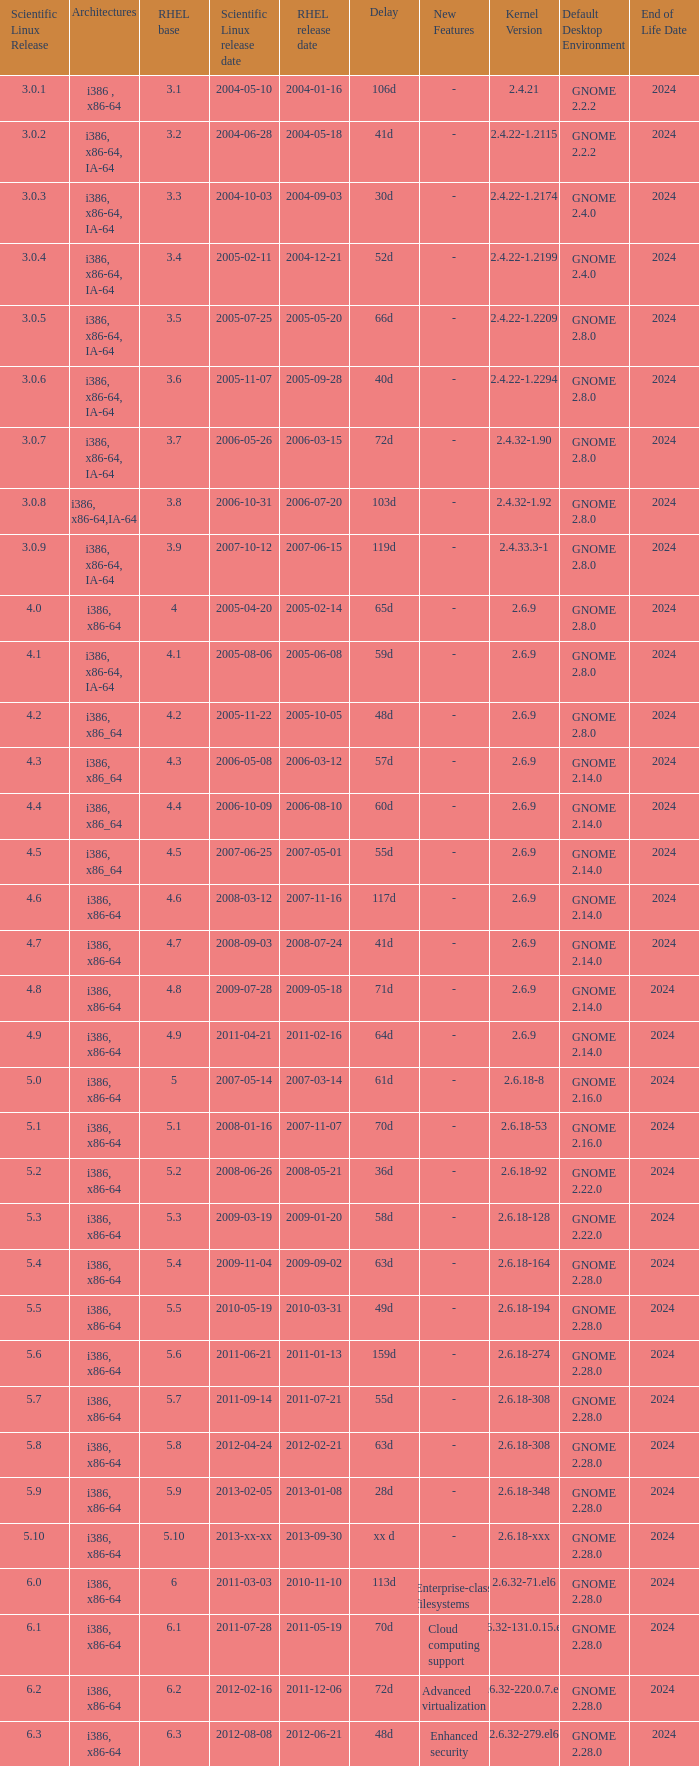When is the rhel release date when scientific linux release is 3.0.4 2004-12-21. 